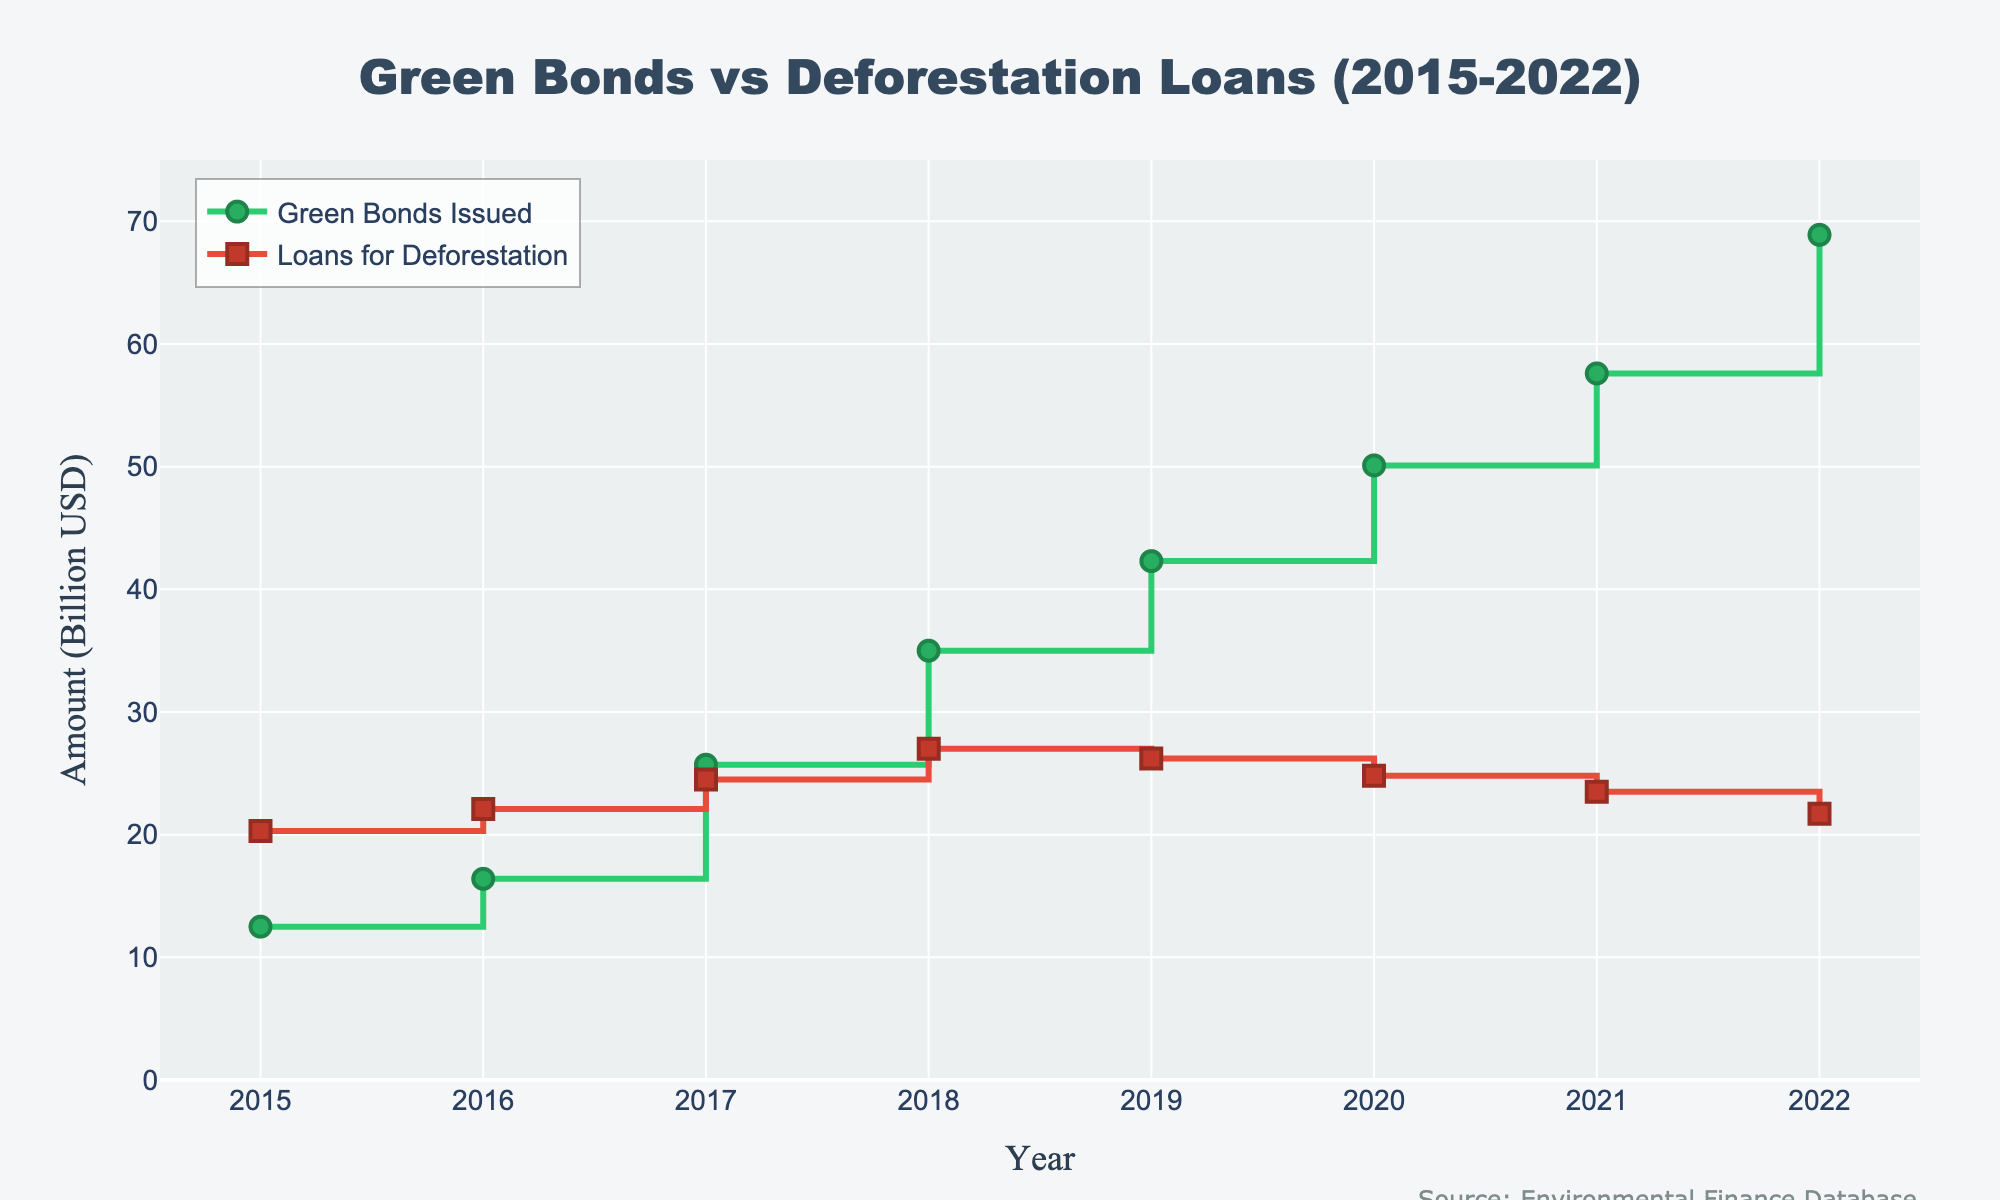What's the title of the figure? The title of a figure is typically placed at the top and provides a brief description of what the chart represents. In this case, it's "Green Bonds vs Deforestation Loans (2015-2022)".
Answer: Green Bonds vs Deforestation Loans (2015-2022) What are the two types of financial activities shown in the figure? The figure shows data for "Green Bonds Issued" and "Loans for Deforestation Activities". These are represented by two separate lines on the plot.
Answer: Green Bonds Issued and Loans for Deforestation Activities Which year saw the highest amount of green bonds issued? By looking at the peak value along the line representing green bonds (the green line), we can see that the highest point is in 2022.
Answer: 2022 How did the amount of loans for deforestation activities change over time? Observing the red line on the plot, it shows fluctuating values but an overall slight decline from 2015 to 2022.
Answer: Slightly decreased In which year were the amounts for green bonds issued and loans for deforestation activities closest to each other? By comparing both lines year by year, 2019 shows them being the closest, with green bonds at 42.3 billion USD and loans for deforestation at 26.2 billion USD.
Answer: 2019 What's the difference in the amount of green bonds issued between 2015 and 2022? To find this, subtract the green bonds amount in 2015 (12.5 billion USD) from that in 2022 (68.9 billion USD). 68.9 - 12.5 = 56.4 billion USD.
Answer: 56.4 billion USD In which year did the loans for deforestation activities reach their maximum value? By locating the highest point on the red line, we can see that the maximum value for loans for deforestation activities was in 2018.
Answer: 2018 How does the amount of green bonds issued in 2020 compare with the amount of loans for deforestation activities in the same year? The green bonds issued (50.1 billion USD) were higher than the loans for deforestation activities (24.8 billion USD) in 2020.
Answer: Green bonds were higher What's the average annual increase in green bonds issued from 2015 to 2022? First, calculate the total increase in green bonds issued over the period: 68.9 - 12.5 = 56.4 billion USD. Then divide it by the number of years (2022-2015=7 years). 56.4 / 7 = 8.06 billion USD per year.
Answer: 8.06 billion USD per year 